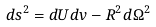<formula> <loc_0><loc_0><loc_500><loc_500>d s ^ { 2 } = d U d v - R ^ { 2 } d \Omega ^ { 2 }</formula> 